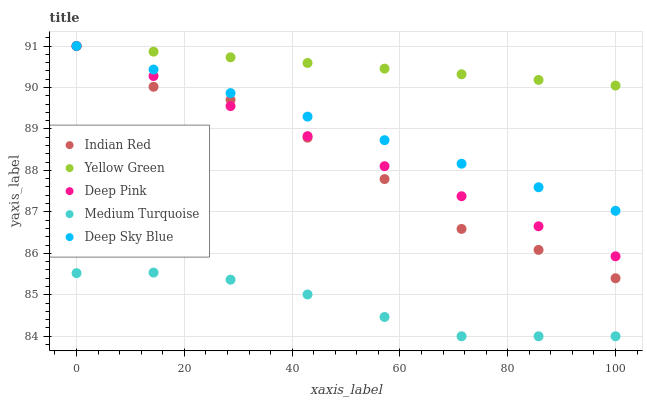Does Medium Turquoise have the minimum area under the curve?
Answer yes or no. Yes. Does Yellow Green have the maximum area under the curve?
Answer yes or no. Yes. Does Deep Pink have the minimum area under the curve?
Answer yes or no. No. Does Deep Pink have the maximum area under the curve?
Answer yes or no. No. Is Deep Sky Blue the smoothest?
Answer yes or no. Yes. Is Indian Red the roughest?
Answer yes or no. Yes. Is Medium Turquoise the smoothest?
Answer yes or no. No. Is Medium Turquoise the roughest?
Answer yes or no. No. Does Medium Turquoise have the lowest value?
Answer yes or no. Yes. Does Deep Pink have the lowest value?
Answer yes or no. No. Does Indian Red have the highest value?
Answer yes or no. Yes. Does Medium Turquoise have the highest value?
Answer yes or no. No. Is Medium Turquoise less than Indian Red?
Answer yes or no. Yes. Is Deep Sky Blue greater than Medium Turquoise?
Answer yes or no. Yes. Does Deep Pink intersect Yellow Green?
Answer yes or no. Yes. Is Deep Pink less than Yellow Green?
Answer yes or no. No. Is Deep Pink greater than Yellow Green?
Answer yes or no. No. Does Medium Turquoise intersect Indian Red?
Answer yes or no. No. 